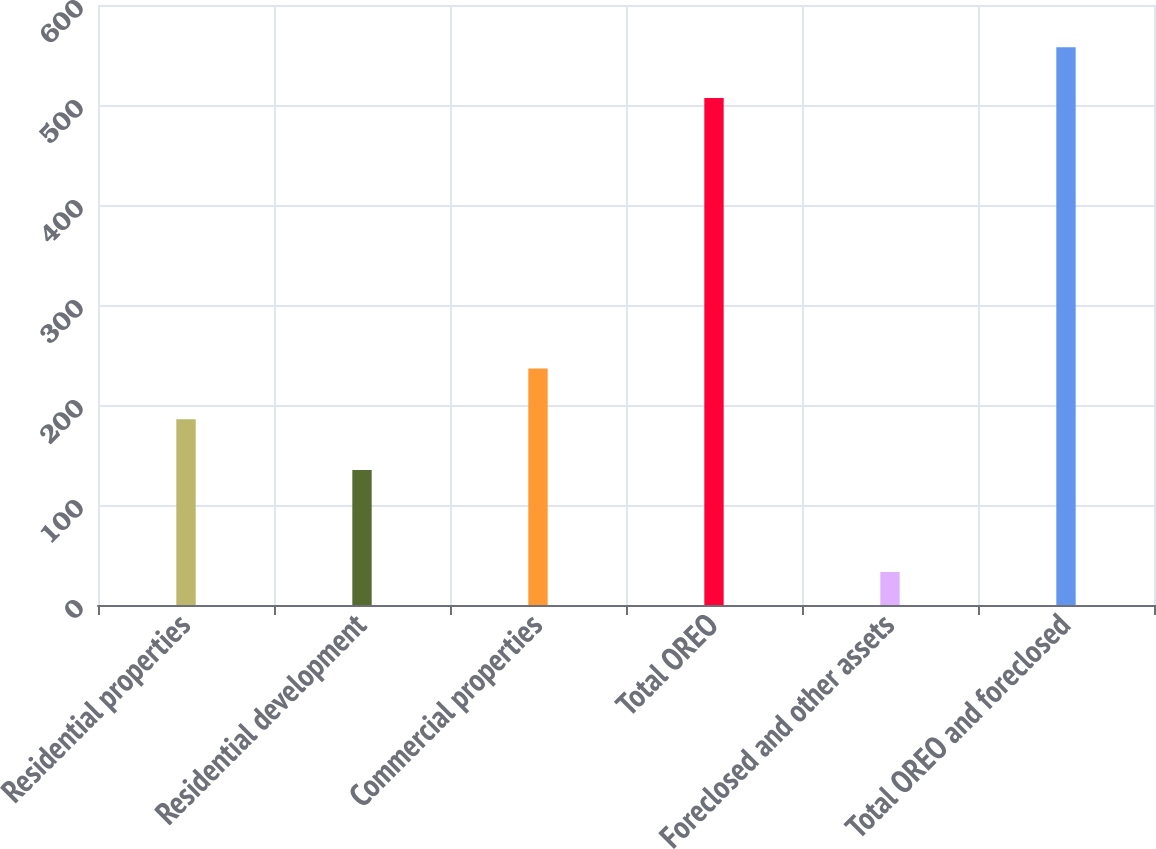<chart> <loc_0><loc_0><loc_500><loc_500><bar_chart><fcel>Residential properties<fcel>Residential development<fcel>Commercial properties<fcel>Total OREO<fcel>Foreclosed and other assets<fcel>Total OREO and foreclosed<nl><fcel>185.7<fcel>135<fcel>236.4<fcel>507<fcel>33<fcel>557.7<nl></chart> 